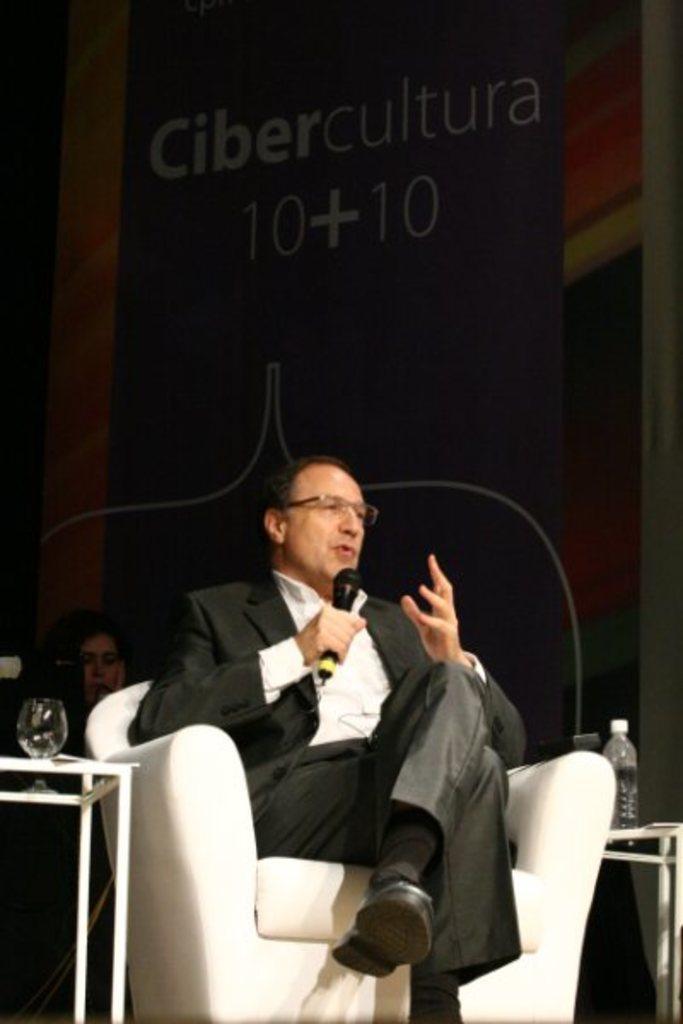Describe this image in one or two sentences. I can see in this image man is sitting on a chair and holding a microphone in his hand. The man is wearing a black suit. Here I can see two tables which has bottle, glass on it. 